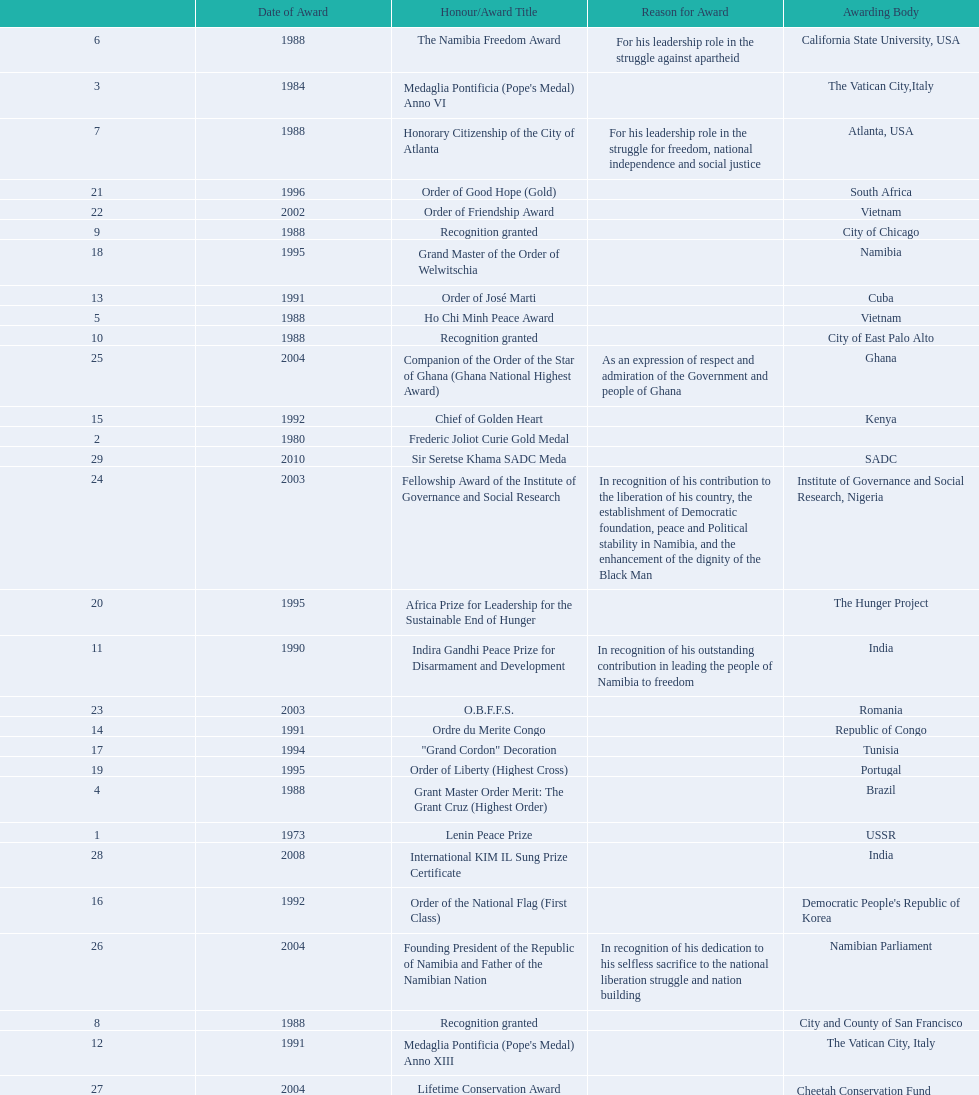Could you parse the entire table? {'header': ['', 'Date of Award', 'Honour/Award Title', 'Reason for Award', 'Awarding Body'], 'rows': [['6', '1988', 'The Namibia Freedom Award', 'For his leadership role in the struggle against apartheid', 'California State University, USA'], ['3', '1984', "Medaglia Pontificia (Pope's Medal) Anno VI", '', 'The Vatican City,Italy'], ['7', '1988', 'Honorary Citizenship of the City of Atlanta', 'For his leadership role in the struggle for freedom, national independence and social justice', 'Atlanta, USA'], ['21', '1996', 'Order of Good Hope (Gold)', '', 'South Africa'], ['22', '2002', 'Order of Friendship Award', '', 'Vietnam'], ['9', '1988', 'Recognition granted', '', 'City of Chicago'], ['18', '1995', 'Grand Master of the Order of Welwitschia', '', 'Namibia'], ['13', '1991', 'Order of José Marti', '', 'Cuba'], ['5', '1988', 'Ho Chi Minh Peace Award', '', 'Vietnam'], ['10', '1988', 'Recognition granted', '', 'City of East Palo Alto'], ['25', '2004', 'Companion of the Order of the Star of Ghana (Ghana National Highest Award)', 'As an expression of respect and admiration of the Government and people of Ghana', 'Ghana'], ['15', '1992', 'Chief of Golden Heart', '', 'Kenya'], ['2', '1980', 'Frederic Joliot Curie Gold Medal', '', ''], ['29', '2010', 'Sir Seretse Khama SADC Meda', '', 'SADC'], ['24', '2003', 'Fellowship Award of the Institute of Governance and Social Research', 'In recognition of his contribution to the liberation of his country, the establishment of Democratic foundation, peace and Political stability in Namibia, and the enhancement of the dignity of the Black Man', 'Institute of Governance and Social Research, Nigeria'], ['20', '1995', 'Africa Prize for Leadership for the Sustainable End of Hunger', '', 'The Hunger Project'], ['11', '1990', 'Indira Gandhi Peace Prize for Disarmament and Development', 'In recognition of his outstanding contribution in leading the people of Namibia to freedom', 'India'], ['23', '2003', 'O.B.F.F.S.', '', 'Romania'], ['14', '1991', 'Ordre du Merite Congo', '', 'Republic of Congo'], ['17', '1994', '"Grand Cordon" Decoration', '', 'Tunisia'], ['19', '1995', 'Order of Liberty (Highest Cross)', '', 'Portugal'], ['4', '1988', 'Grant Master Order Merit: The Grant Cruz (Highest Order)', '', 'Brazil'], ['1', '1973', 'Lenin Peace Prize', '', 'USSR'], ['28', '2008', 'International KIM IL Sung Prize Certificate', '', 'India'], ['16', '1992', 'Order of the National Flag (First Class)', '', "Democratic People's Republic of Korea"], ['26', '2004', 'Founding President of the Republic of Namibia and Father of the Namibian Nation', 'In recognition of his dedication to his selfless sacrifice to the national liberation struggle and nation building', 'Namibian Parliament'], ['8', '1988', 'Recognition granted', '', 'City and County of San Francisco'], ['12', '1991', "Medaglia Pontificia (Pope's Medal) Anno XIII", '', 'The Vatican City, Italy'], ['27', '2004', 'Lifetime Conservation Award', '', 'Cheetah Conservation Fund (Nujoma is the international patron of this organisation since 1991)']]} What is the last honors/award title listed on this chart? Sir Seretse Khama SADC Meda. 